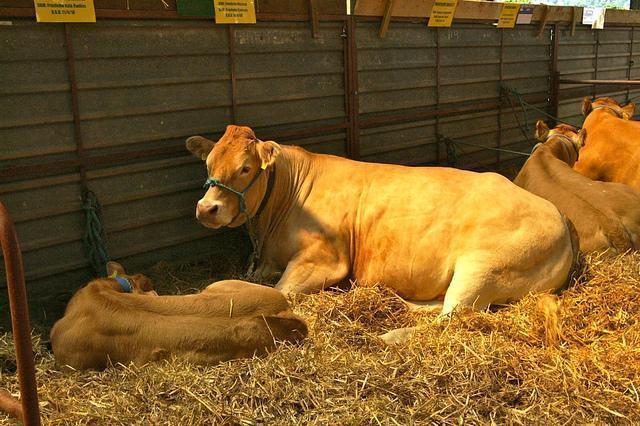What color is the handle tied around the sunlit cow's face?
Choose the right answer from the provided options to respond to the question.
Options: Blue, green, red, yellow. Green. 